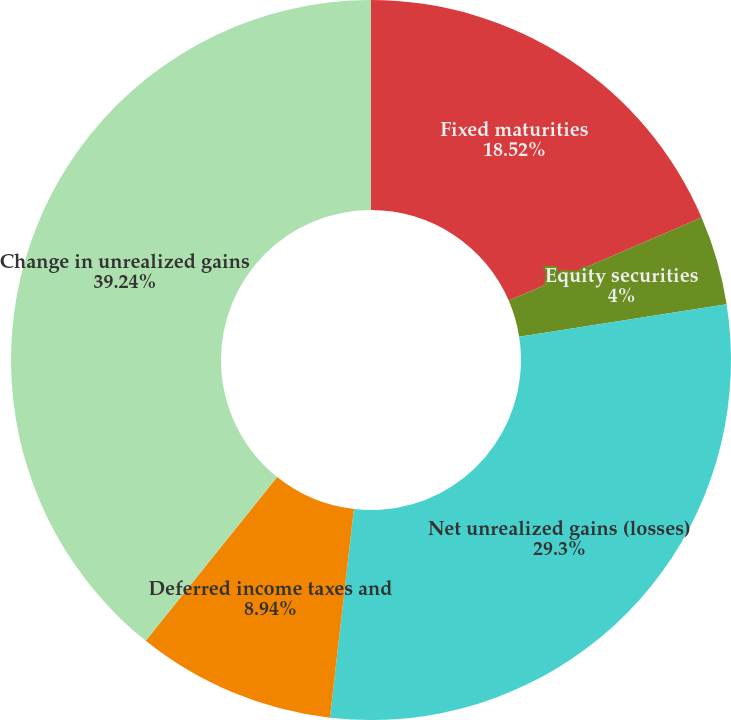Convert chart. <chart><loc_0><loc_0><loc_500><loc_500><pie_chart><fcel>Fixed maturities<fcel>Equity securities<fcel>Net unrealized gains (losses)<fcel>Deferred income taxes and<fcel>Change in unrealized gains<nl><fcel>18.52%<fcel>4.0%<fcel>29.3%<fcel>8.94%<fcel>39.24%<nl></chart> 